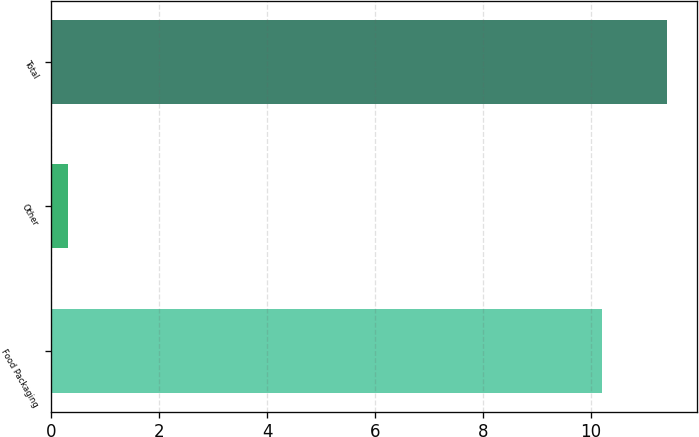Convert chart to OTSL. <chart><loc_0><loc_0><loc_500><loc_500><bar_chart><fcel>Food Packaging<fcel>Other<fcel>Total<nl><fcel>10.2<fcel>0.3<fcel>11.4<nl></chart> 